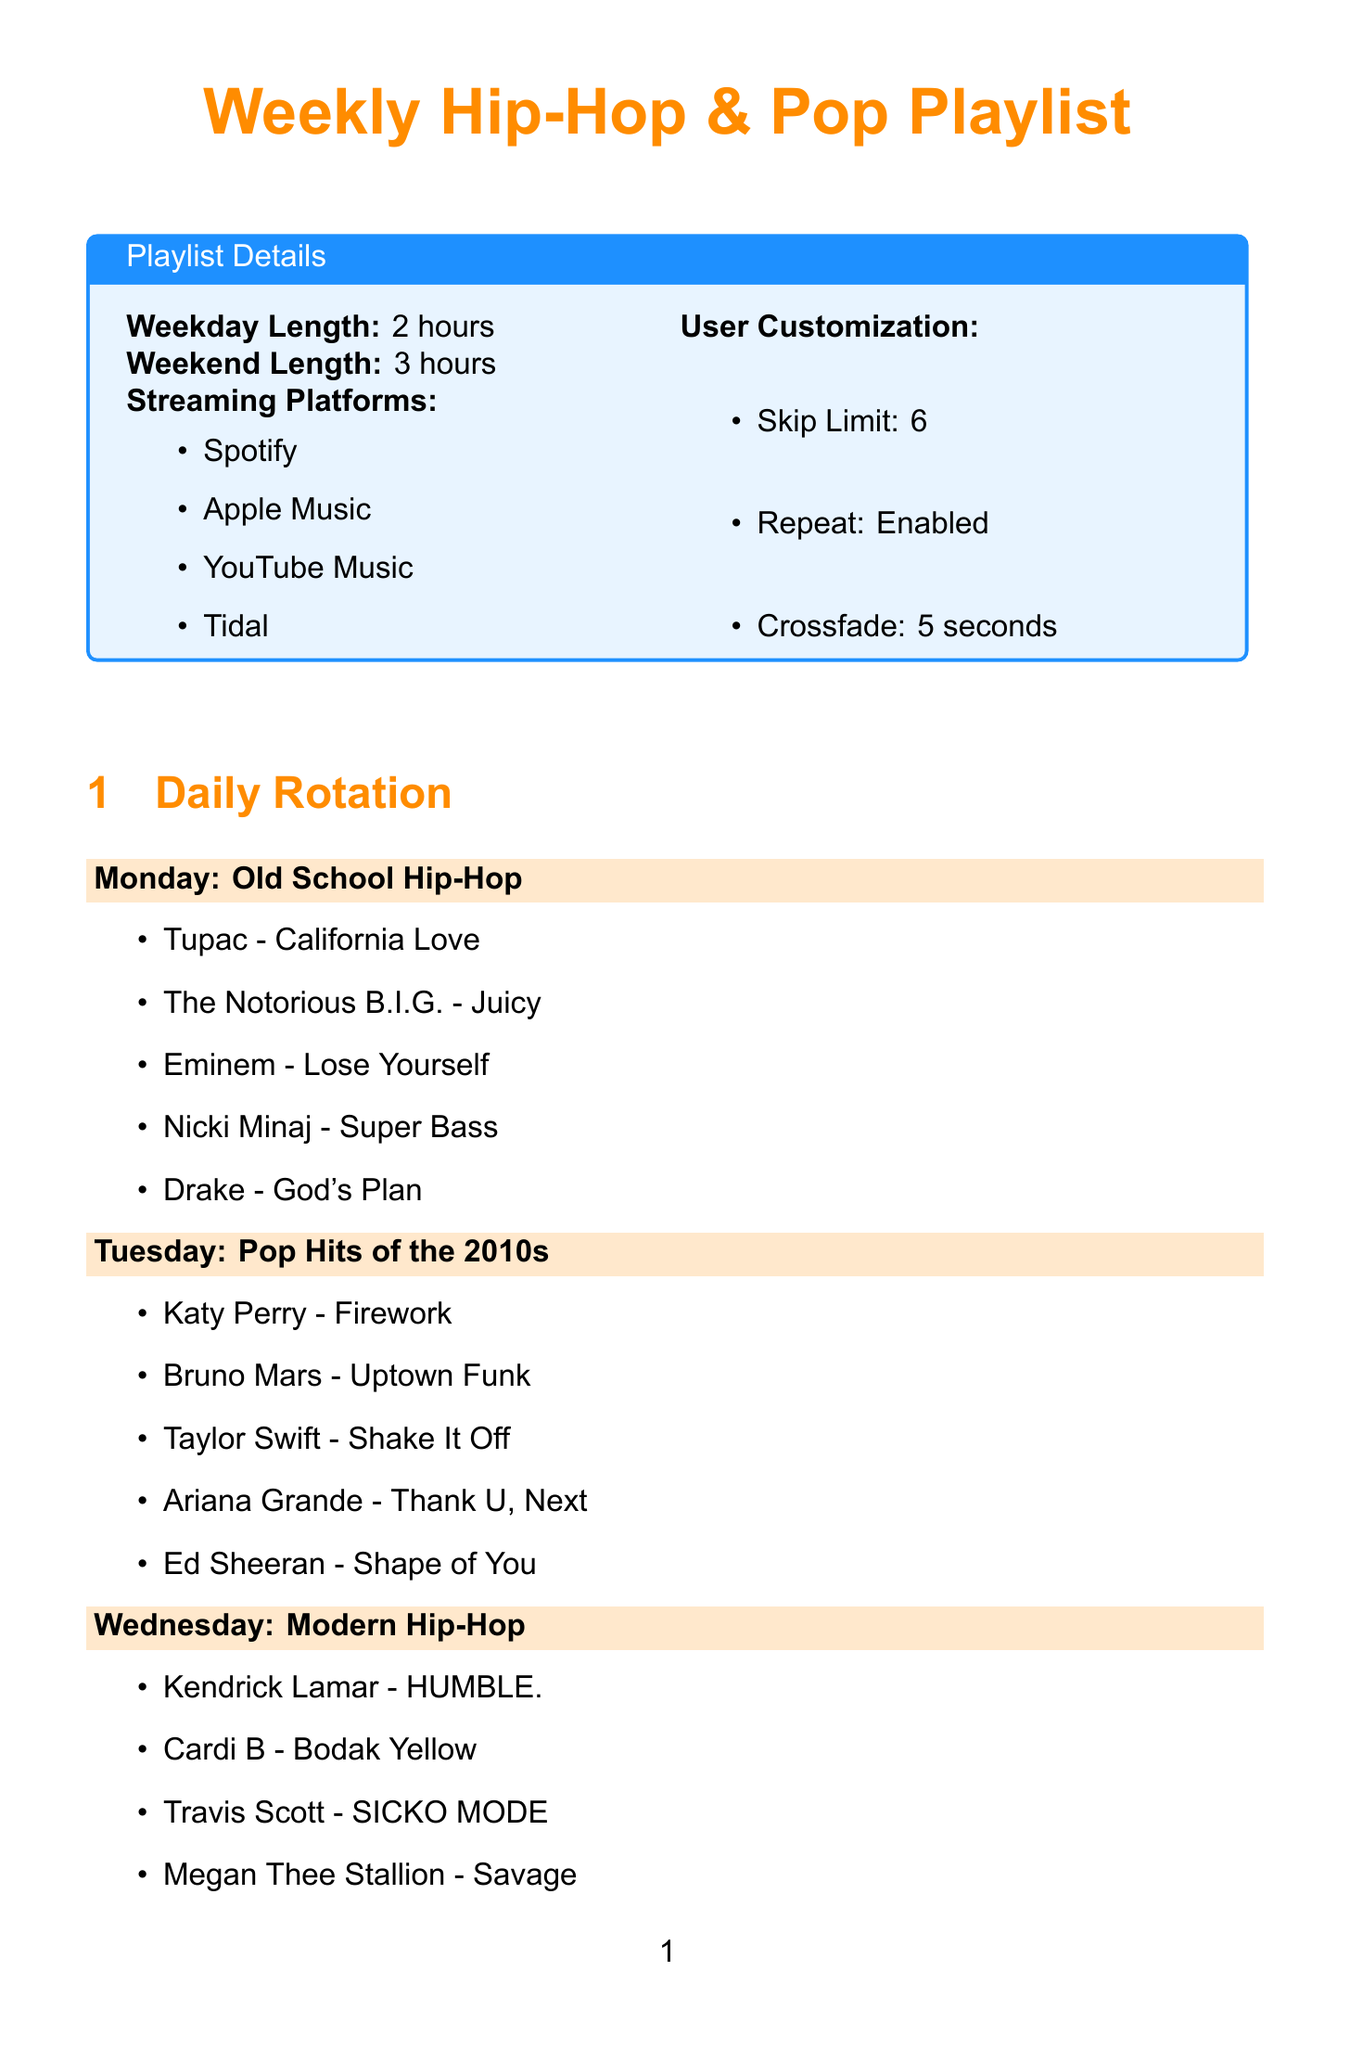what is the theme for Monday? The theme for Monday is specified in the daily rotation section of the document.
Answer: Old School Hip-Hop how many tracks are featured on Saturday? The number of tracks is listed under each day's rotation in the document.
Answer: 5 which track features Eminem and Rihanna? The collaboration track featuring Eminem and Rihanna is mentioned in the Friday section.
Answer: Love The Way You Lie what is the length of the playlist on weekends? The document specifies the lengths for weekdays and weekends in the playlist details.
Answer: 3 hours what special feature occurs every Thursday? The special feature dedicated to Thursdays is explicitly described in the special features section.
Answer: Throwback Thursday which streaming platforms are mentioned? The streaming platforms are listed in the playlist details section.
Answer: Spotify, Apple Music, YouTube Music, Tidal how many newly released tracks are featured on Fridays? The number of new tracks is specified under the New Music Friday special feature in the document.
Answer: At least two which artist is featured in the Sunday chill session? The artists featured on Sunday are provided in the daily rotation section.
Answer: Frank Ocean what customization option allows for skipping tracks? The user customization options include specific features regarding track management.
Answer: Skip Limit how many days are dedicated to hip-hop in the rotation? The number of days dedicated to hip-hop can be inferred from the daily themes listed in the document.
Answer: 4 